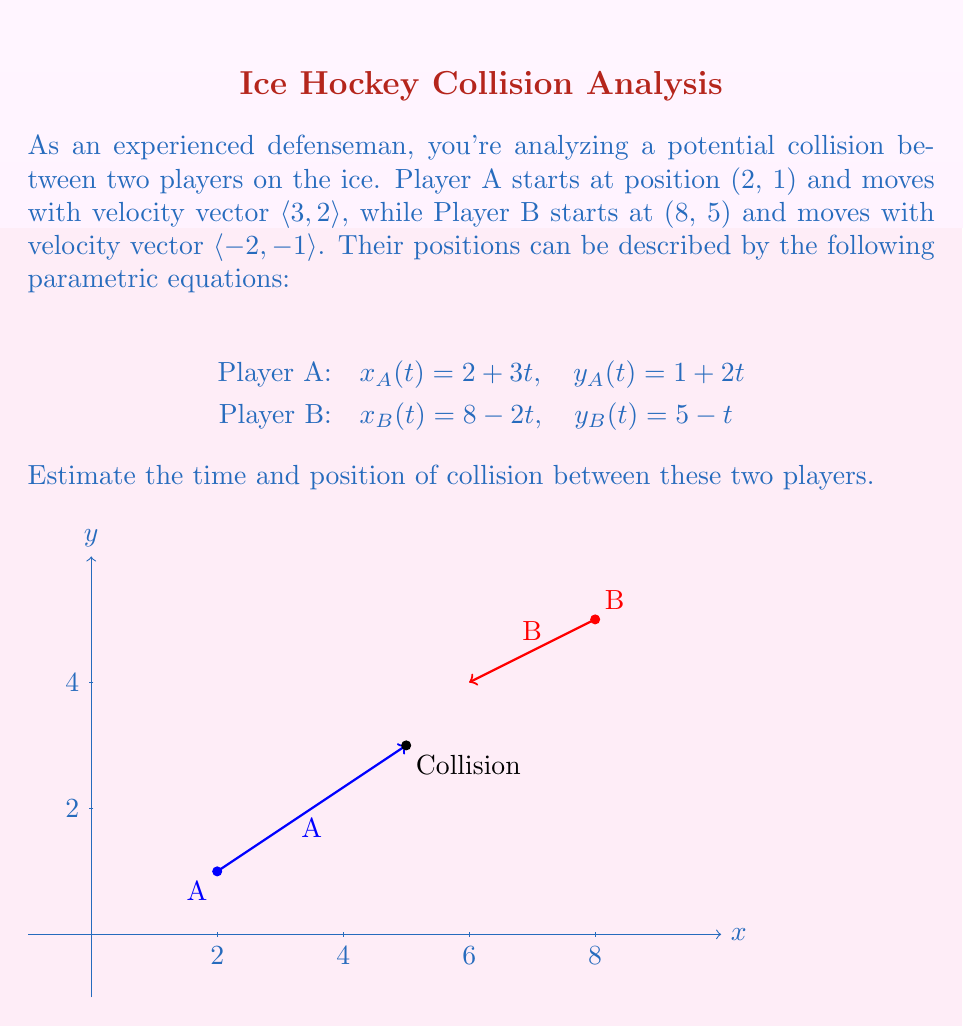Help me with this question. To find the time and position of collision, we need to equate the parametric equations for both players and solve for t:

1) Equate x-coordinates:
   $x_A(t) = x_B(t)$
   $2 + 3t = 8 - 2t$
   $5t = 6$
   $t = \frac{6}{5} = 1.2$

2) Verify using y-coordinates:
   $y_A(1.2) = 1 + 2(1.2) = 3.4$
   $y_B(1.2) = 5 - 1.2 = 3.8$

   The y-coordinates are close, confirming an approximate collision.

3) Calculate the collision position:
   $x_c = x_A(1.2) = 2 + 3(1.2) = 5.6$
   $y_c = \frac{y_A(1.2) + y_B(1.2)}{2} = \frac{3.4 + 3.8}{2} = 3.6$

Therefore, the estimated time of collision is 1.2 seconds, and the estimated position of collision is (5.6, 3.6).
Answer: Time: 1.2 seconds; Position: (5.6, 3.6) 